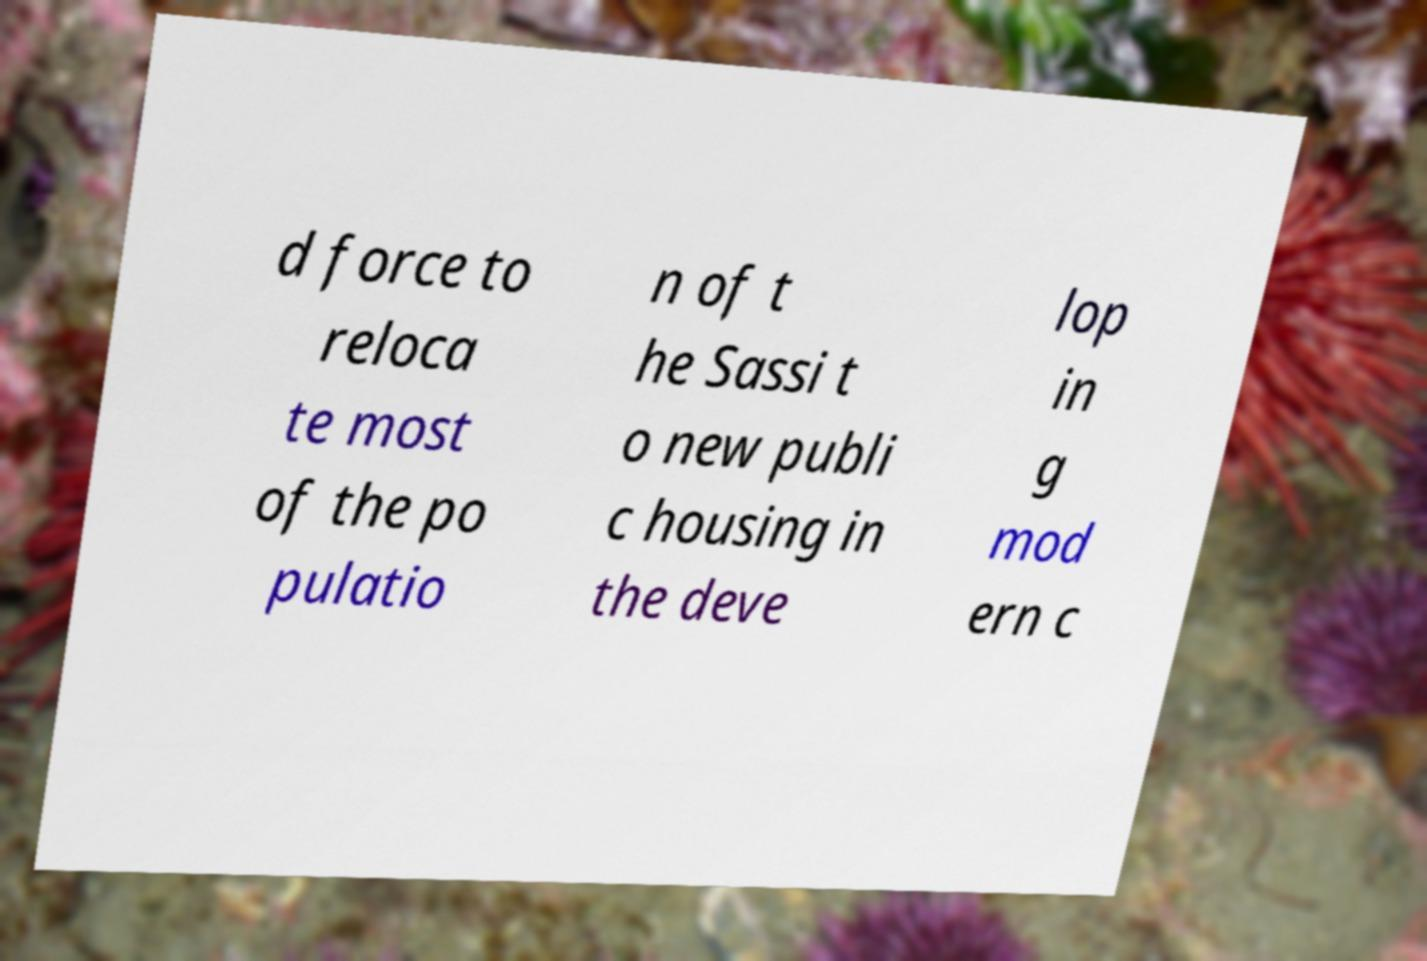Can you accurately transcribe the text from the provided image for me? d force to reloca te most of the po pulatio n of t he Sassi t o new publi c housing in the deve lop in g mod ern c 